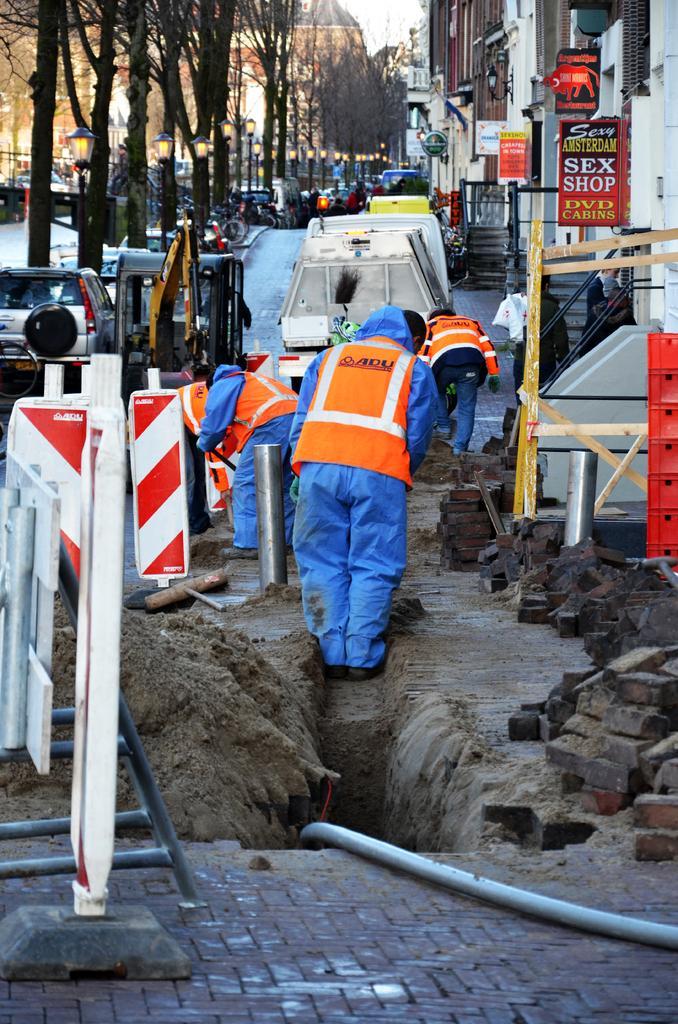Please provide a concise description of this image. In this image there is a path and there are people digging the path and there are cars, trees, buildings, bricks and a pipe. 